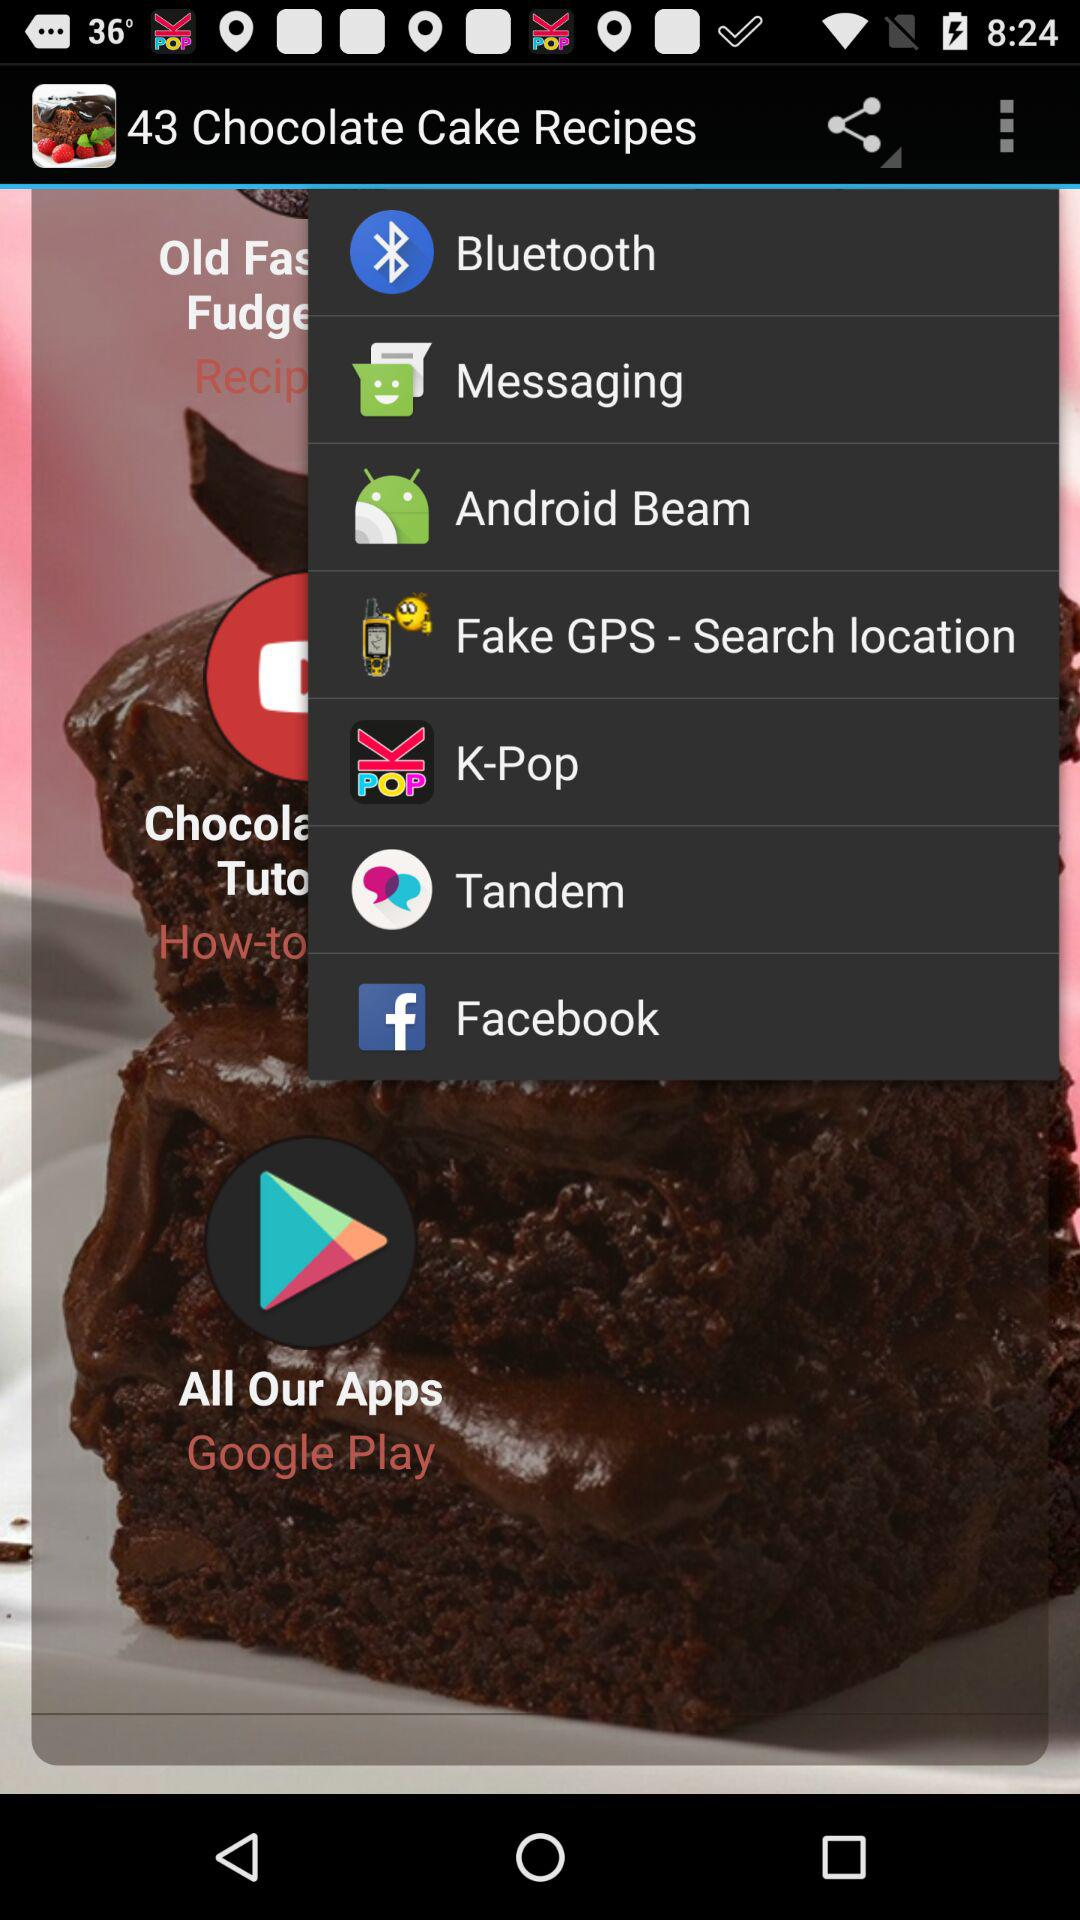What is the count of chocolate cake recipes? The count is 43. 